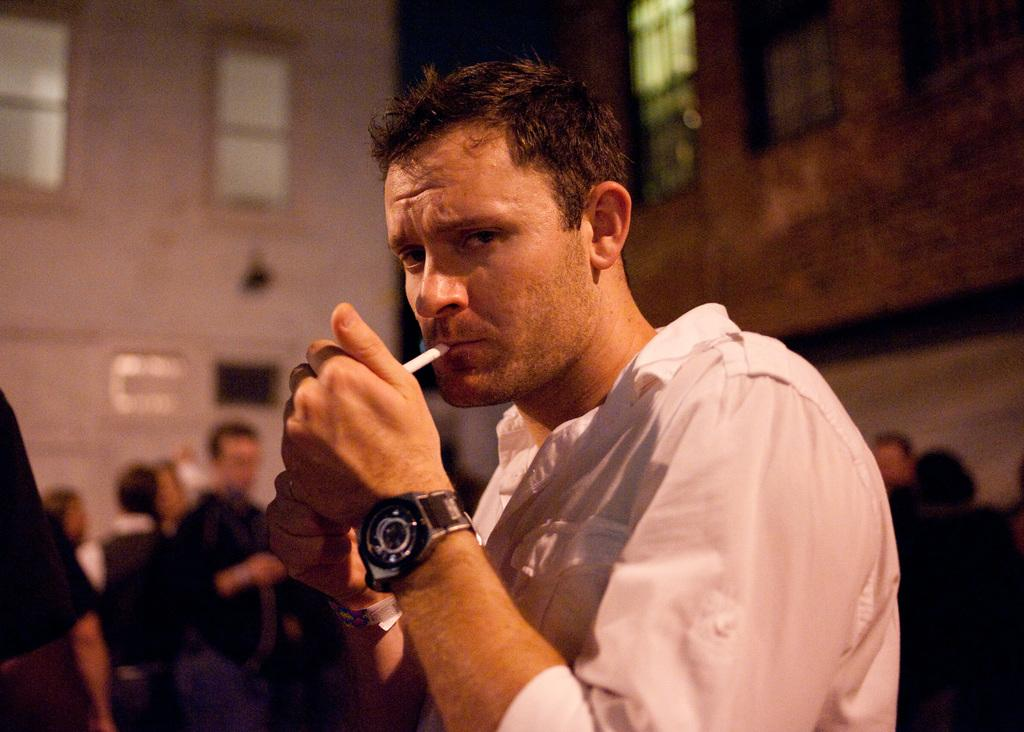What is the man in the image holding? The man in the image is holding a cigarette. How many people are present in the image? There is a group of people standing in the image. What can be seen in the background of the image? There are walls with windows in the background of the image. What type of plastic object can be seen in the hands of the man in the image? There is no plastic object visible in the man's hands in the image; he is holding a cigarette. What class is being taught in the image? There is no class or educational setting depicted in the image. 